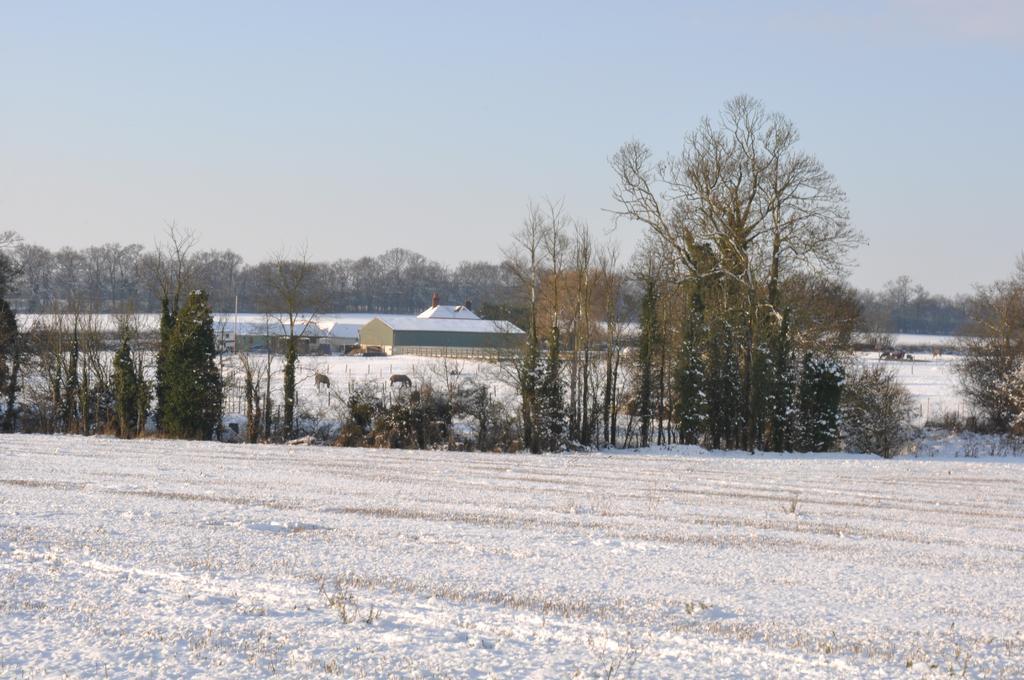How would you summarize this image in a sentence or two? In this image we can see trees. On the ground there is snow. In the background there are trees, buildings and sky. 